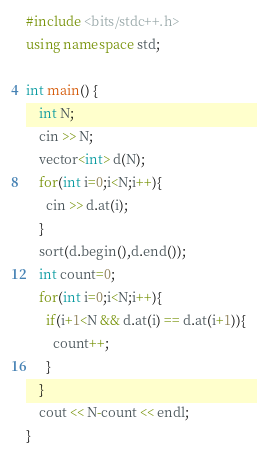<code> <loc_0><loc_0><loc_500><loc_500><_C++_>#include <bits/stdc++.h>
using namespace std;

int main() {
	int N;
	cin >> N;
    vector<int> d(N);
    for(int i=0;i<N;i++){
      cin >> d.at(i);
    }
    sort(d.begin(),d.end());
    int count=0;
    for(int i=0;i<N;i++){
      if(i+1<N && d.at(i) == d.at(i+1)){
        count++;
      }
    }
    cout << N-count << endl;
}
</code> 